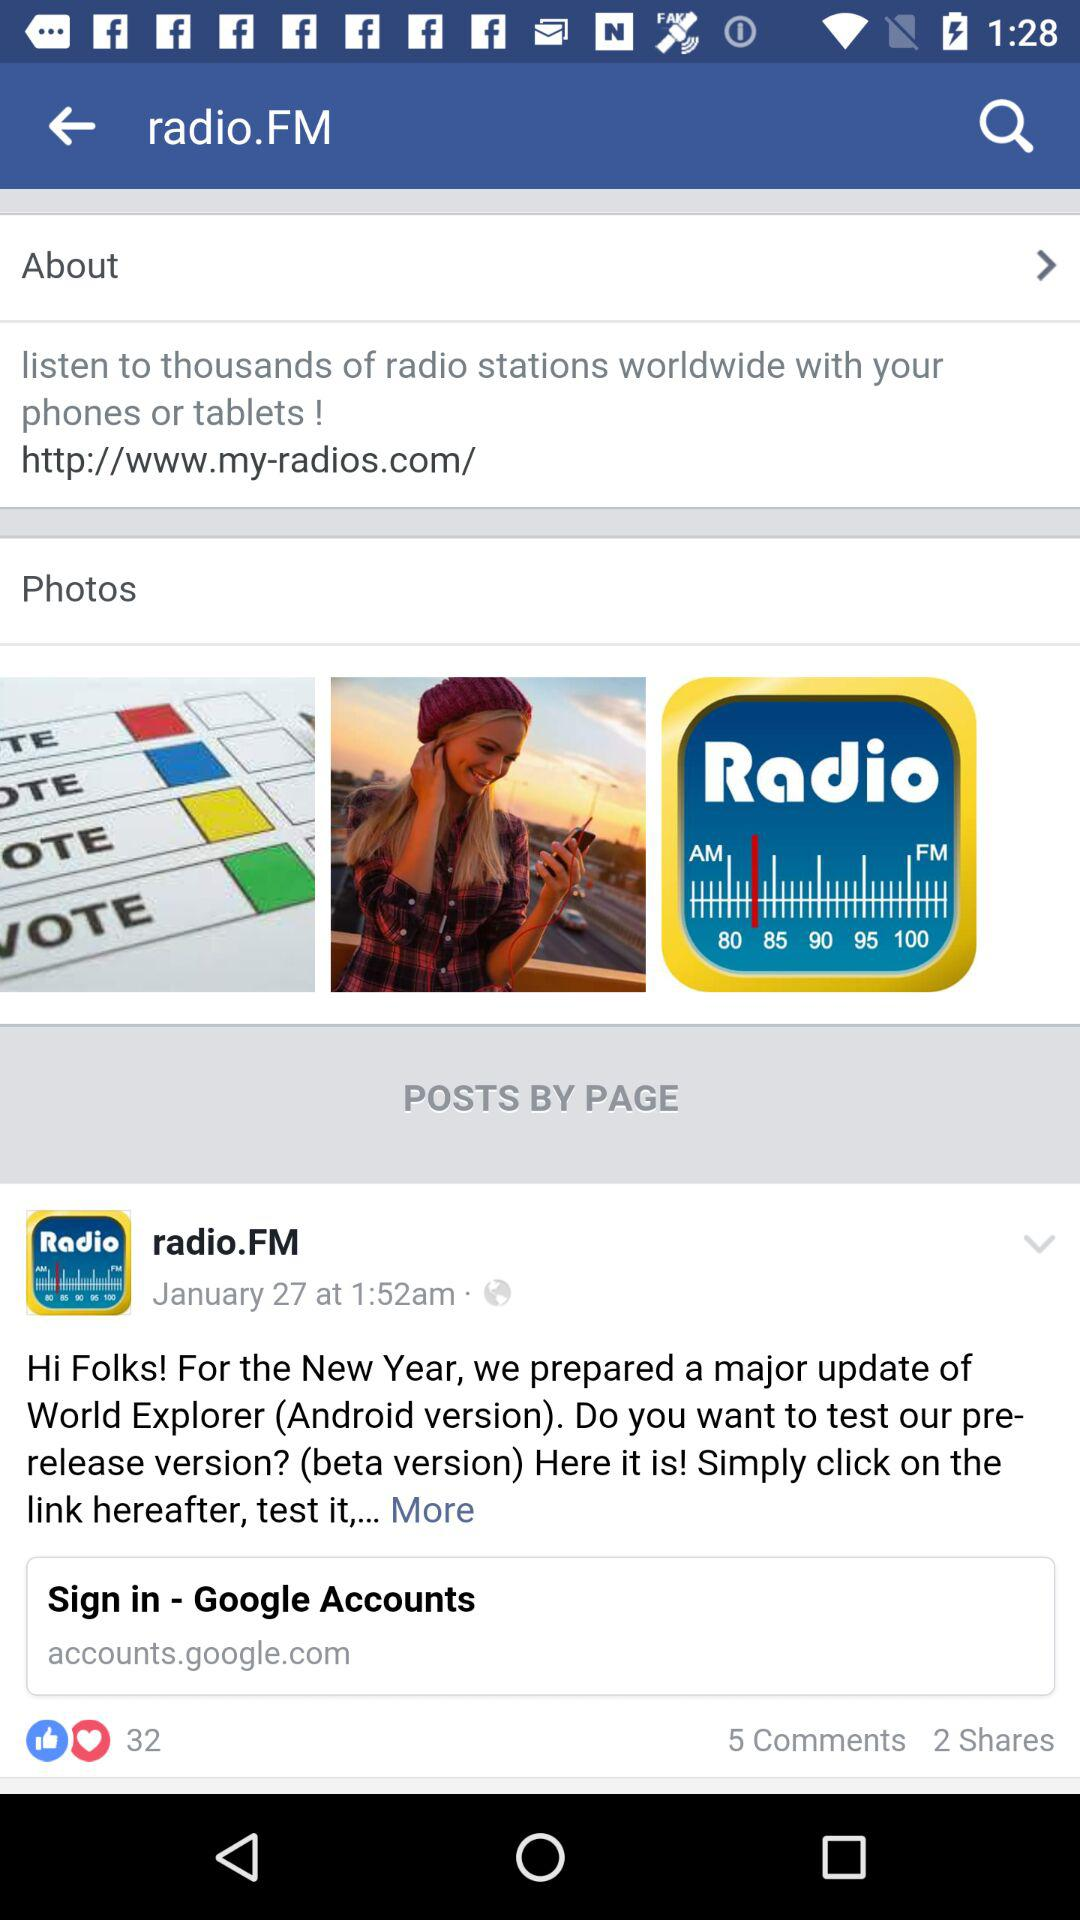How many more comments than shares does this post have?
Answer the question using a single word or phrase. 3 